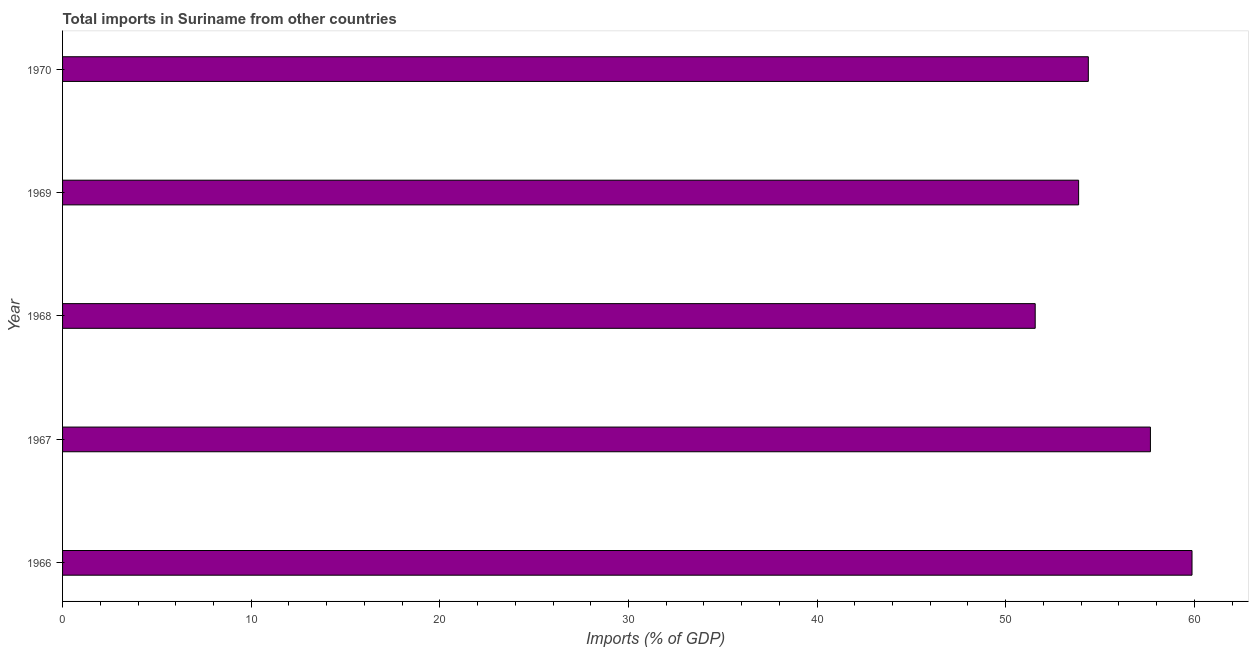Does the graph contain any zero values?
Provide a succinct answer. No. What is the title of the graph?
Your answer should be compact. Total imports in Suriname from other countries. What is the label or title of the X-axis?
Offer a terse response. Imports (% of GDP). What is the total imports in 1966?
Give a very brief answer. 59.88. Across all years, what is the maximum total imports?
Give a very brief answer. 59.88. Across all years, what is the minimum total imports?
Provide a short and direct response. 51.56. In which year was the total imports maximum?
Provide a succinct answer. 1966. In which year was the total imports minimum?
Offer a very short reply. 1968. What is the sum of the total imports?
Ensure brevity in your answer.  277.36. What is the difference between the total imports in 1967 and 1968?
Your response must be concise. 6.11. What is the average total imports per year?
Ensure brevity in your answer.  55.47. What is the median total imports?
Give a very brief answer. 54.38. Do a majority of the years between 1966 and 1967 (inclusive) have total imports greater than 48 %?
Your answer should be compact. Yes. What is the difference between the highest and the second highest total imports?
Offer a very short reply. 2.21. Is the sum of the total imports in 1967 and 1968 greater than the maximum total imports across all years?
Offer a very short reply. Yes. What is the difference between the highest and the lowest total imports?
Offer a terse response. 8.31. In how many years, is the total imports greater than the average total imports taken over all years?
Make the answer very short. 2. Are all the bars in the graph horizontal?
Provide a short and direct response. Yes. How many years are there in the graph?
Offer a terse response. 5. Are the values on the major ticks of X-axis written in scientific E-notation?
Keep it short and to the point. No. What is the Imports (% of GDP) of 1966?
Your answer should be compact. 59.88. What is the Imports (% of GDP) of 1967?
Your answer should be very brief. 57.67. What is the Imports (% of GDP) of 1968?
Keep it short and to the point. 51.56. What is the Imports (% of GDP) in 1969?
Provide a short and direct response. 53.87. What is the Imports (% of GDP) in 1970?
Your answer should be very brief. 54.38. What is the difference between the Imports (% of GDP) in 1966 and 1967?
Your response must be concise. 2.21. What is the difference between the Imports (% of GDP) in 1966 and 1968?
Provide a short and direct response. 8.31. What is the difference between the Imports (% of GDP) in 1966 and 1969?
Provide a succinct answer. 6.01. What is the difference between the Imports (% of GDP) in 1966 and 1970?
Your response must be concise. 5.5. What is the difference between the Imports (% of GDP) in 1967 and 1968?
Provide a succinct answer. 6.11. What is the difference between the Imports (% of GDP) in 1967 and 1969?
Keep it short and to the point. 3.81. What is the difference between the Imports (% of GDP) in 1967 and 1970?
Ensure brevity in your answer.  3.29. What is the difference between the Imports (% of GDP) in 1968 and 1969?
Your answer should be compact. -2.3. What is the difference between the Imports (% of GDP) in 1968 and 1970?
Offer a very short reply. -2.82. What is the difference between the Imports (% of GDP) in 1969 and 1970?
Your answer should be very brief. -0.51. What is the ratio of the Imports (% of GDP) in 1966 to that in 1967?
Keep it short and to the point. 1.04. What is the ratio of the Imports (% of GDP) in 1966 to that in 1968?
Your answer should be compact. 1.16. What is the ratio of the Imports (% of GDP) in 1966 to that in 1969?
Ensure brevity in your answer.  1.11. What is the ratio of the Imports (% of GDP) in 1966 to that in 1970?
Give a very brief answer. 1.1. What is the ratio of the Imports (% of GDP) in 1967 to that in 1968?
Your answer should be compact. 1.12. What is the ratio of the Imports (% of GDP) in 1967 to that in 1969?
Offer a terse response. 1.07. What is the ratio of the Imports (% of GDP) in 1967 to that in 1970?
Give a very brief answer. 1.06. What is the ratio of the Imports (% of GDP) in 1968 to that in 1970?
Your answer should be compact. 0.95. What is the ratio of the Imports (% of GDP) in 1969 to that in 1970?
Provide a succinct answer. 0.99. 